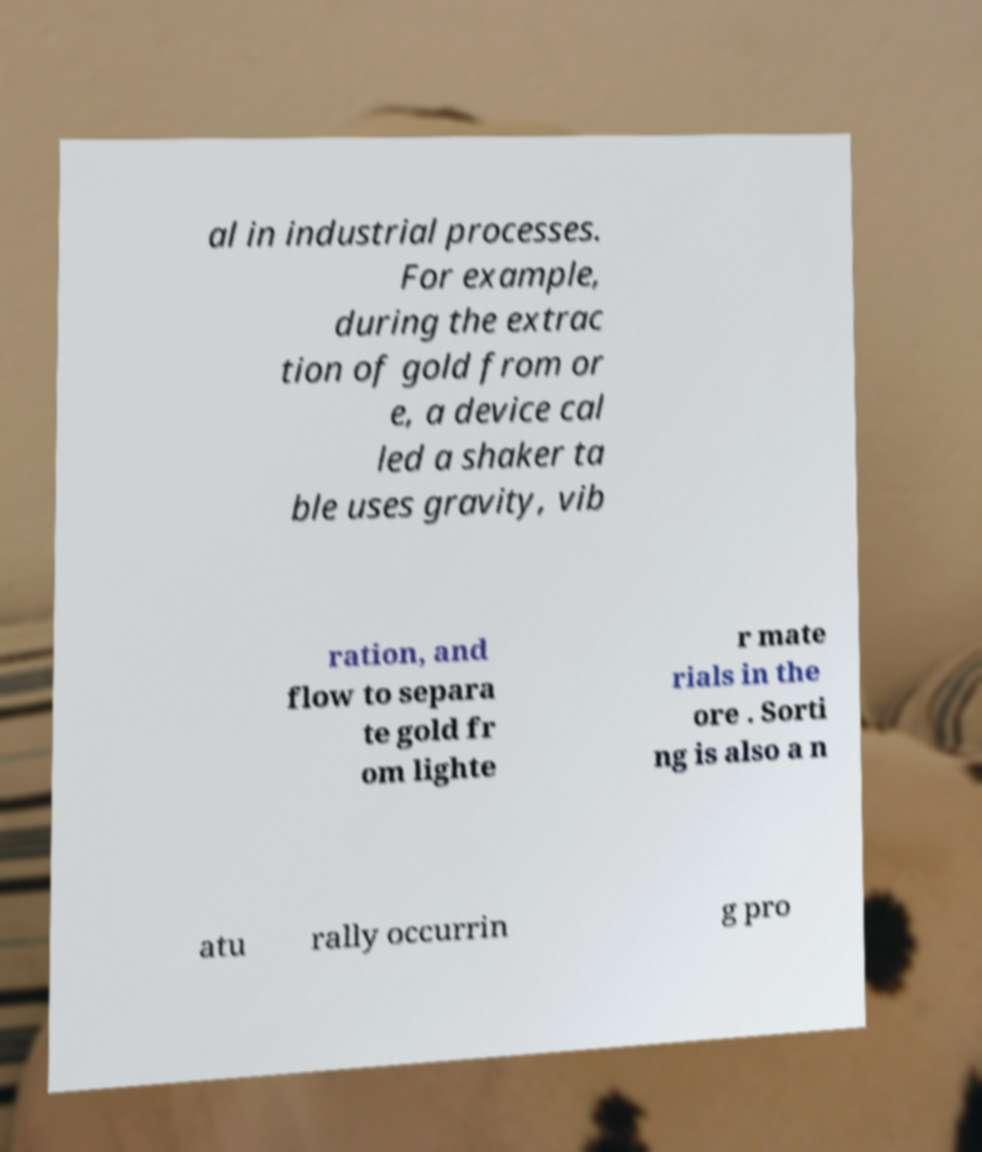What messages or text are displayed in this image? I need them in a readable, typed format. al in industrial processes. For example, during the extrac tion of gold from or e, a device cal led a shaker ta ble uses gravity, vib ration, and flow to separa te gold fr om lighte r mate rials in the ore . Sorti ng is also a n atu rally occurrin g pro 